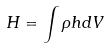Convert formula to latex. <formula><loc_0><loc_0><loc_500><loc_500>H = \int \rho h d V</formula> 